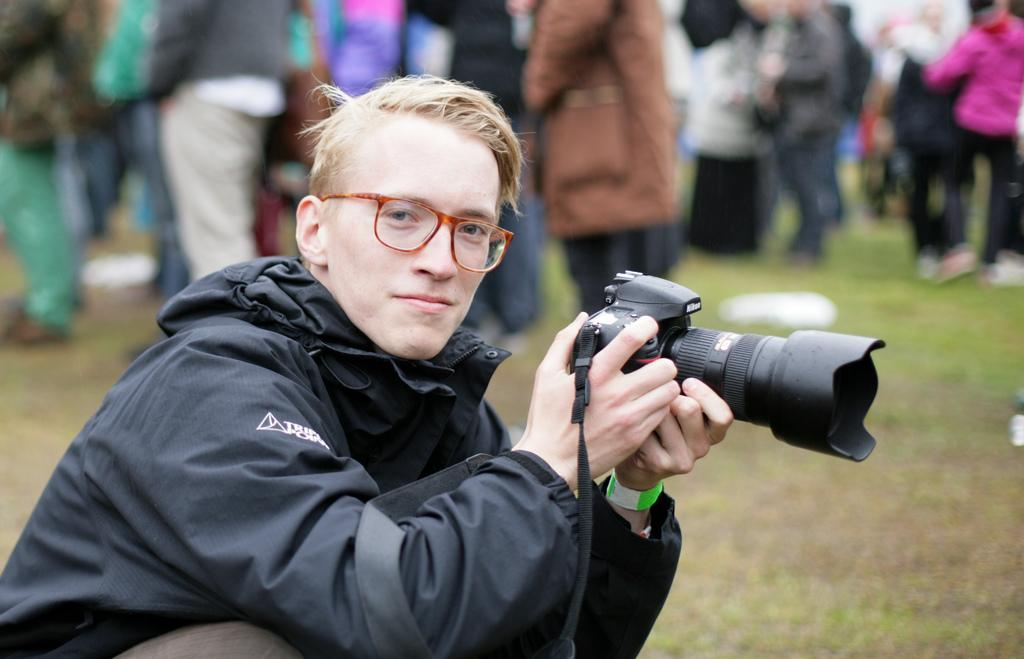Who is the main subject in the image? There is a man in the image. What is the man wearing? The man is wearing a black jacket. What is the man holding in the image? The man is holding a camera. What can be seen in the background of the image? There are people in the background of the image. What type of ground is visible in the image? There is grass on the ground in the image. What type of jeans is the man wearing in the image? The provided facts do not mention the man wearing jeans; he is wearing a black jacket. Is the man wearing a cap in the image? The provided facts do not mention the man wearing a cap; he is wearing a black jacket. 